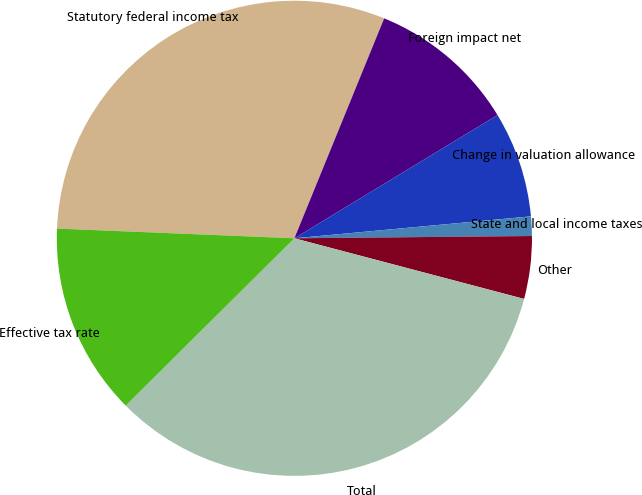Convert chart. <chart><loc_0><loc_0><loc_500><loc_500><pie_chart><fcel>Statutory federal income tax<fcel>Foreign impact net<fcel>Change in valuation allowance<fcel>State and local income taxes<fcel>Other<fcel>Total<fcel>Effective tax rate<nl><fcel>30.52%<fcel>10.15%<fcel>7.21%<fcel>1.32%<fcel>4.26%<fcel>33.46%<fcel>13.09%<nl></chart> 